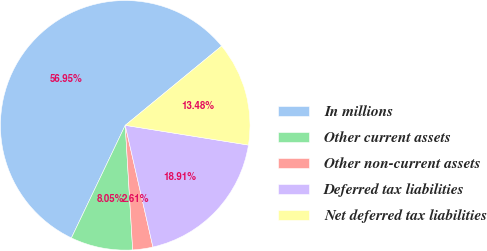Convert chart to OTSL. <chart><loc_0><loc_0><loc_500><loc_500><pie_chart><fcel>In millions<fcel>Other current assets<fcel>Other non-current assets<fcel>Deferred tax liabilities<fcel>Net deferred tax liabilities<nl><fcel>56.95%<fcel>8.05%<fcel>2.61%<fcel>18.91%<fcel>13.48%<nl></chart> 